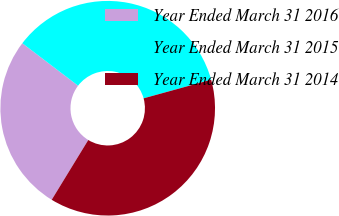<chart> <loc_0><loc_0><loc_500><loc_500><pie_chart><fcel>Year Ended March 31 2016<fcel>Year Ended March 31 2015<fcel>Year Ended March 31 2014<nl><fcel>26.62%<fcel>35.36%<fcel>38.02%<nl></chart> 